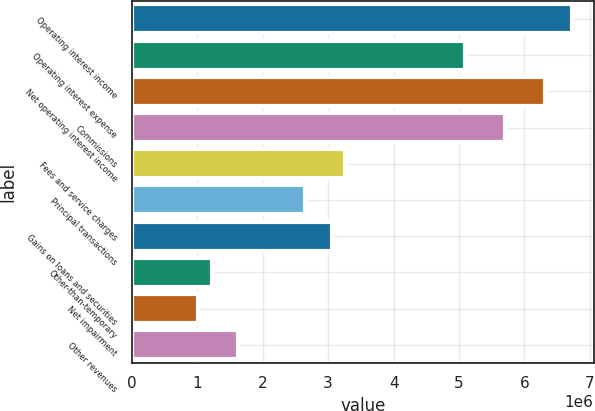<chart> <loc_0><loc_0><loc_500><loc_500><bar_chart><fcel>Operating interest income<fcel>Operating interest expense<fcel>Net operating interest income<fcel>Commissions<fcel>Fees and service charges<fcel>Principal transactions<fcel>Gains on loans and securities<fcel>Other-than-temporary<fcel>Net impairment<fcel>Other revenues<nl><fcel>6.72078e+06<fcel>5.0915e+06<fcel>6.31346e+06<fcel>5.70248e+06<fcel>3.25856e+06<fcel>2.64758e+06<fcel>3.0549e+06<fcel>1.22196e+06<fcel>1.0183e+06<fcel>1.62928e+06<nl></chart> 